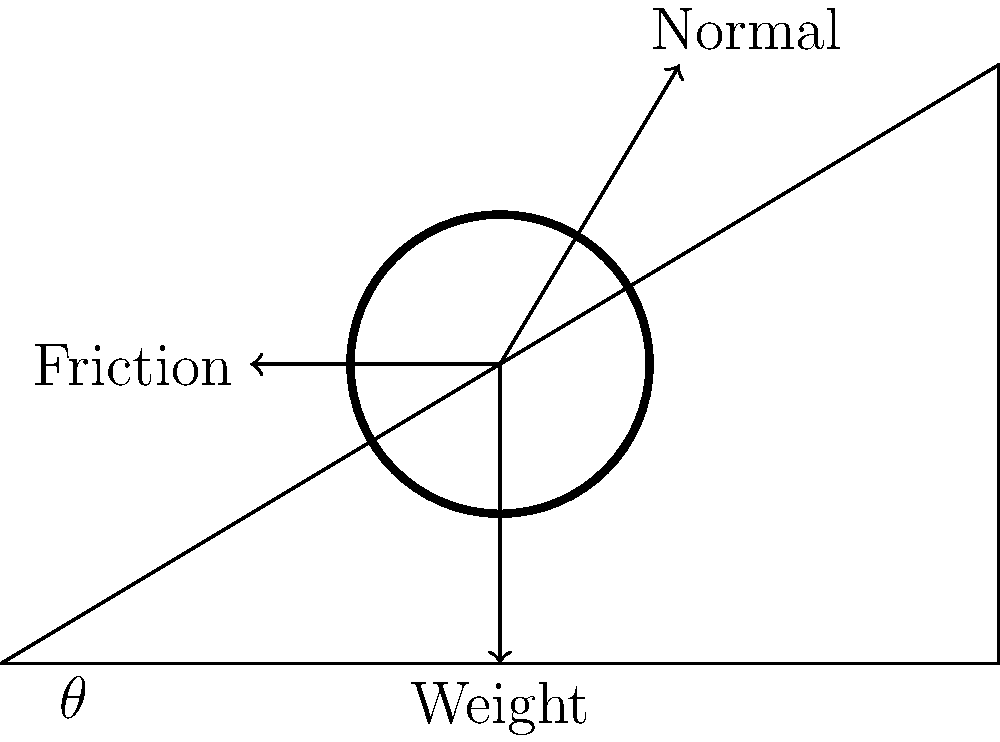A tank is positioned on an inclined plane at an angle $\theta$ to the horizontal. Given that the weight of the tank is 50,000 N and the coefficient of static friction between the tank and the plane is 0.4, what is the maximum angle $\theta$ at which the tank will remain stationary on the incline? Let's approach this step-by-step:

1) For the tank to remain stationary, the component of the force parallel to the incline must be balanced by the friction force.

2) The forces acting on the tank are:
   - Weight (W): 50,000 N, acting vertically downward
   - Normal force (N): perpendicular to the incline
   - Friction force (F): parallel to the incline, opposing motion

3) The component of weight parallel to the incline is $W \sin \theta$, and perpendicular to the incline is $W \cos \theta$.

4) The normal force is equal to the component of weight perpendicular to the incline:
   $N = W \cos \theta$

5) The maximum friction force is given by:
   $F_{max} = \mu N = \mu W \cos \theta$, where $\mu$ is the coefficient of static friction (0.4)

6) For the tank to be on the verge of sliding, the component of weight parallel to the incline must equal the maximum friction force:
   $W \sin \theta = \mu W \cos \theta$

7) Simplifying:
   $\sin \theta = \mu \cos \theta$
   $\tan \theta = \mu$

8) Therefore:
   $\theta = \arctan(\mu) = \arctan(0.4)$

9) Calculate:
   $\theta \approx 21.8°$
Answer: $21.8°$ 